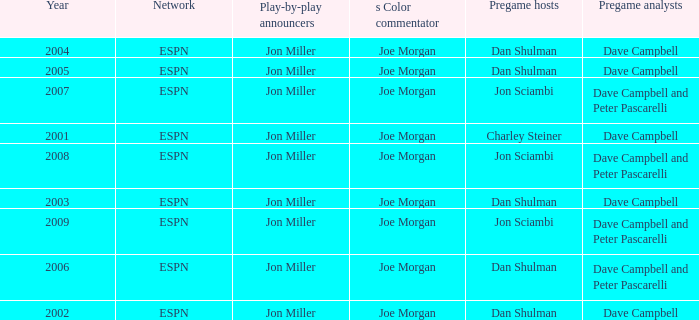How many networks are listed when the year is 2008? 1.0. 